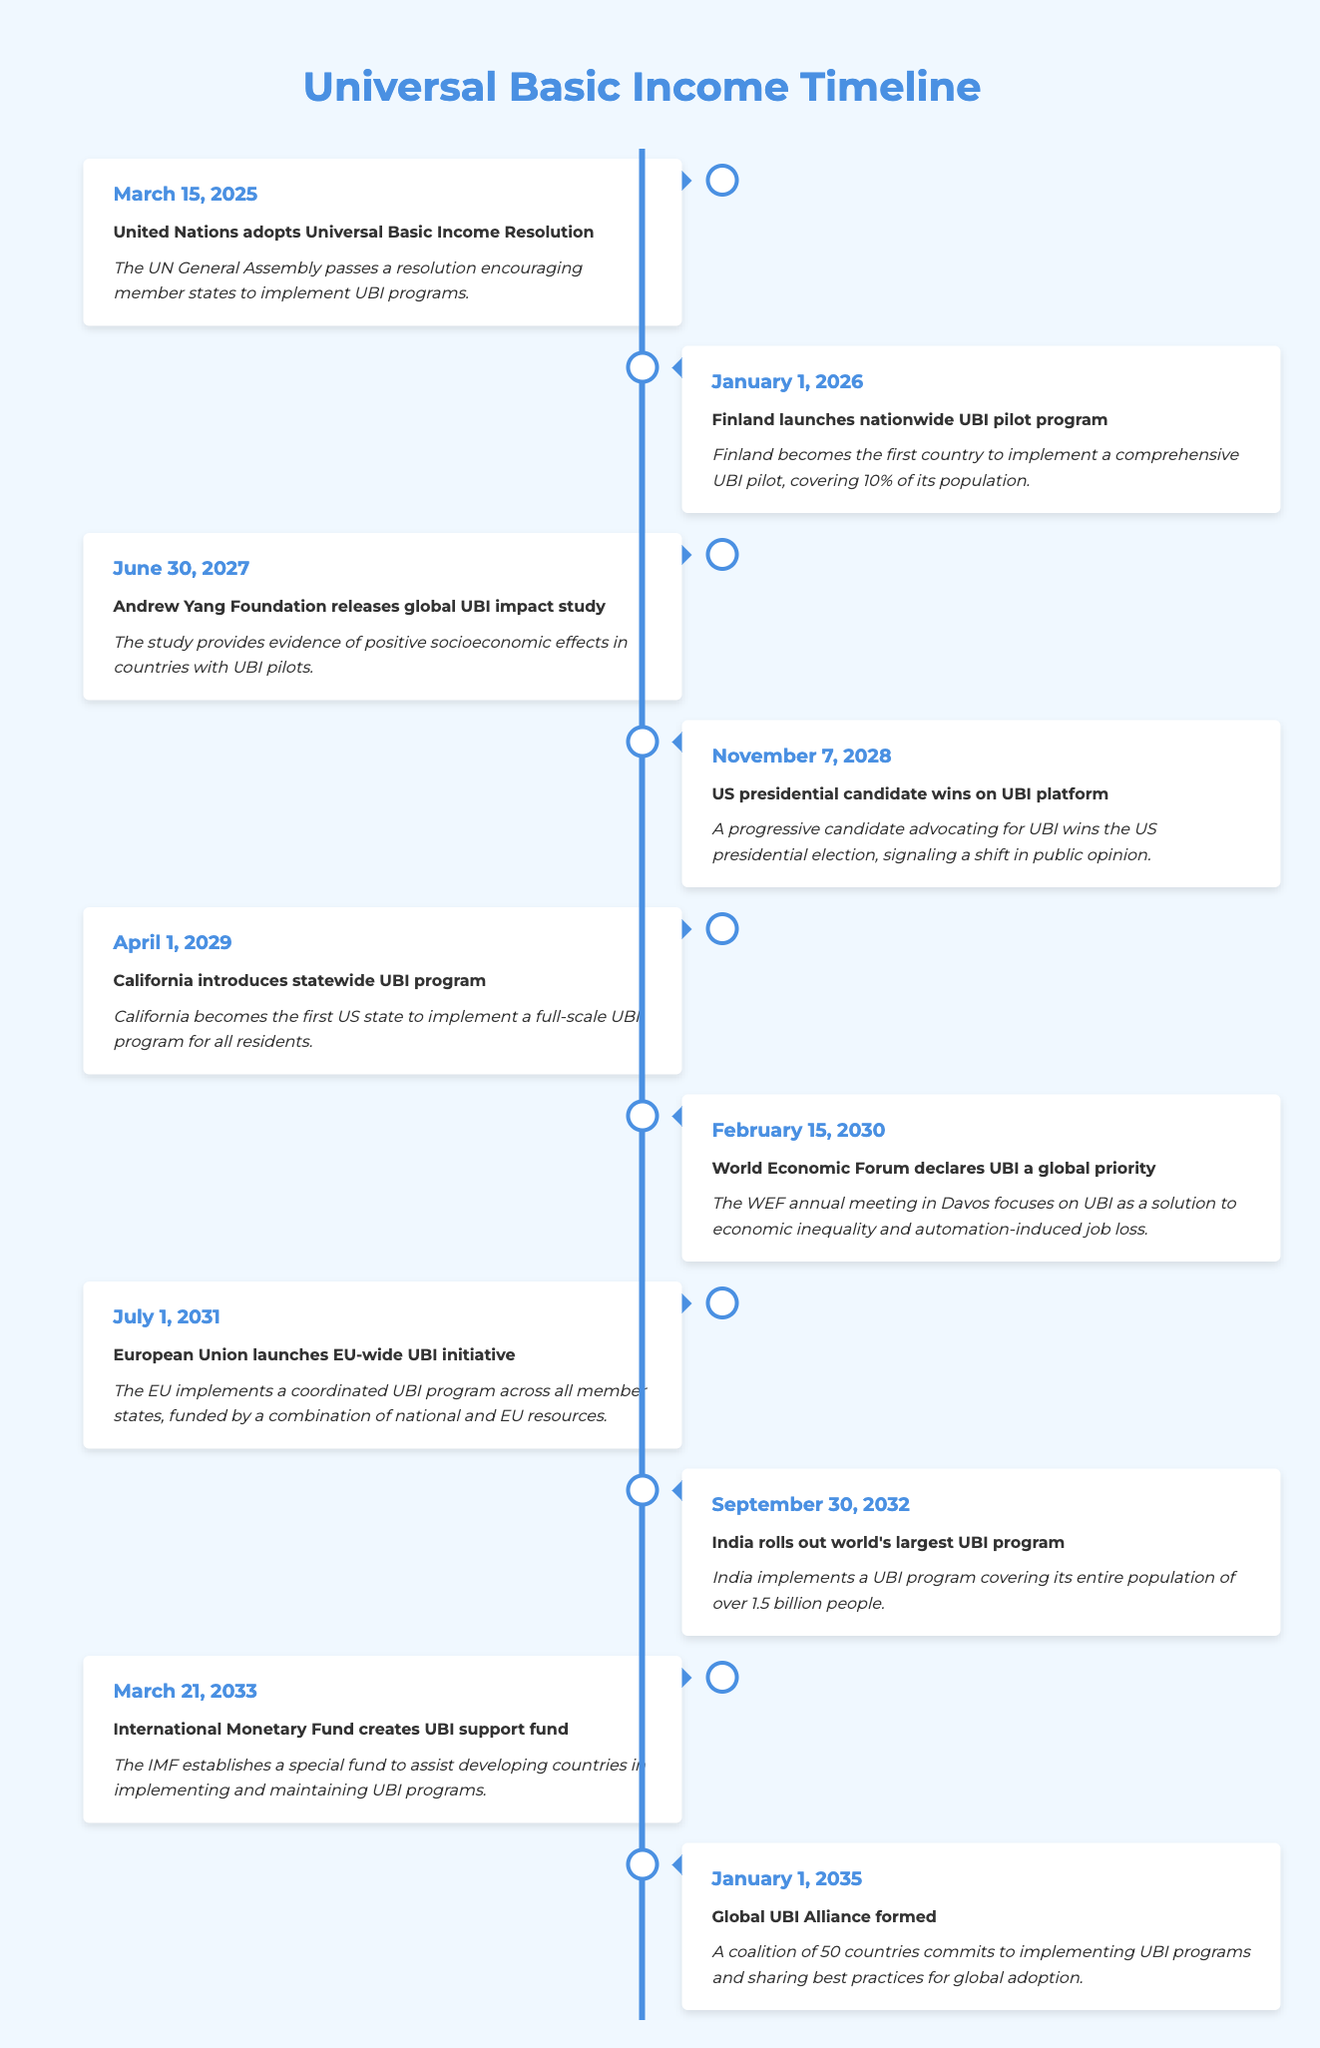What event occurred first in the timeline? The first event in the timeline is the "United Nations adopts Universal Basic Income Resolution" on March 15, 2025. This can be identified by looking at the dates listed in the earlier entries of the table.
Answer: United Nations adopts Universal Basic Income Resolution What year did India roll out its UBI program? According to the table, India rolled out the world's largest UBI program on September 30, 2032. This can be found by locating the event related to India in the timeline.
Answer: 2032 Did the World Economic Forum declare UBI a global priority before California introduced its UBI program? Yes, the World Economic Forum declared UBI a global priority on February 15, 2030, while California introduced its statewide UBI program on April 1, 2029. Comparing these dates confirms the statement.
Answer: Yes How many years spanned between the adoption of the UN resolution and the launch of the EU-wide UBI initiative? The UN resolution was adopted on March 15, 2025, and the EU-wide UBI initiative was launched on July 1, 2031. The difference in years can be calculated by subtracting the earlier date from the later date: 2031 - 2025 = 6 years, noting the months indicate it is more than 6 years but less than 7.
Answer: 6 years What percentage of Finland's population was covered by its UBI pilot program? Finland's UBI pilot program covered 10% of its population as stated in the description of the event that took place on January 1, 2026. This fact can be verified directly in the event details.
Answer: 10% How many total events were documented in the timeline from 2025 to 2035? There are ten events documented in the timeline spanning from March 15, 2025, to January 1, 2035. This can be confirmed by counting each event entry in the table.
Answer: 10 Which event indicates a shift in public opinion towards UBI in the United States? The event indicating a shift in public opinion towards UBI is "US presidential candidate wins on UBI platform" on November 7, 2028. This event specifically mentions the election outcome related to UBI advocacy.
Answer: US presidential candidate wins on UBI platform Is there an event that mentions the establishment of a fund to assist developing countries with UBI? Yes, the "International Monetary Fund creates UBI support fund" on March 21, 2033, explicitly mentions the establishment of a fund to assist developing countries in implementing UBI programs. This is found in the timeline directly under the IMF event.
Answer: Yes In which year was the Global UBI Alliance formed? The Global UBI Alliance was formed on January 1, 2035, as listed at the end of the timeline. This fact can be confirmed by locating the last event in the list.
Answer: 2035 